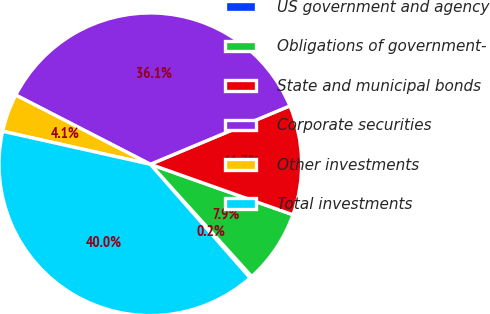Convert chart to OTSL. <chart><loc_0><loc_0><loc_500><loc_500><pie_chart><fcel>US government and agency<fcel>Obligations of government-<fcel>State and municipal bonds<fcel>Corporate securities<fcel>Other investments<fcel>Total investments<nl><fcel>0.23%<fcel>7.89%<fcel>11.72%<fcel>36.13%<fcel>4.06%<fcel>39.96%<nl></chart> 